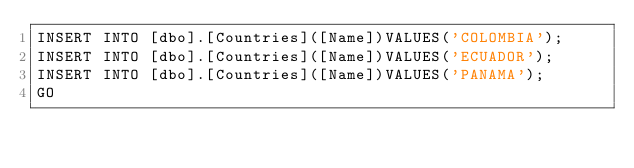Convert code to text. <code><loc_0><loc_0><loc_500><loc_500><_SQL_>INSERT INTO [dbo].[Countries]([Name])VALUES('COLOMBIA');
INSERT INTO [dbo].[Countries]([Name])VALUES('ECUADOR');
INSERT INTO [dbo].[Countries]([Name])VALUES('PANAMA');
GO</code> 